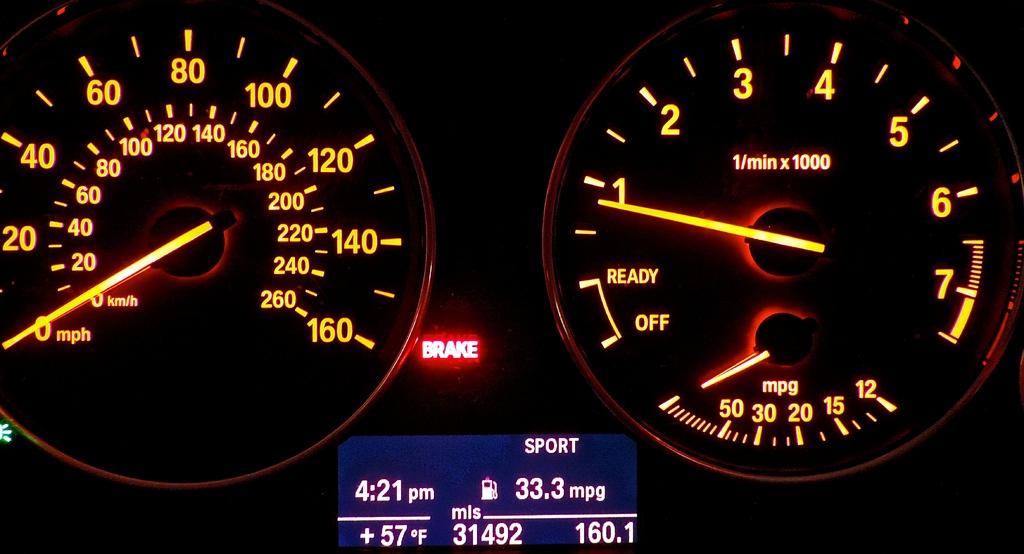How many miles per gallon (mpg) does this vehicle get?
Offer a terse response. 33.3. 33 miles per gallon?
Offer a terse response. Yes. 